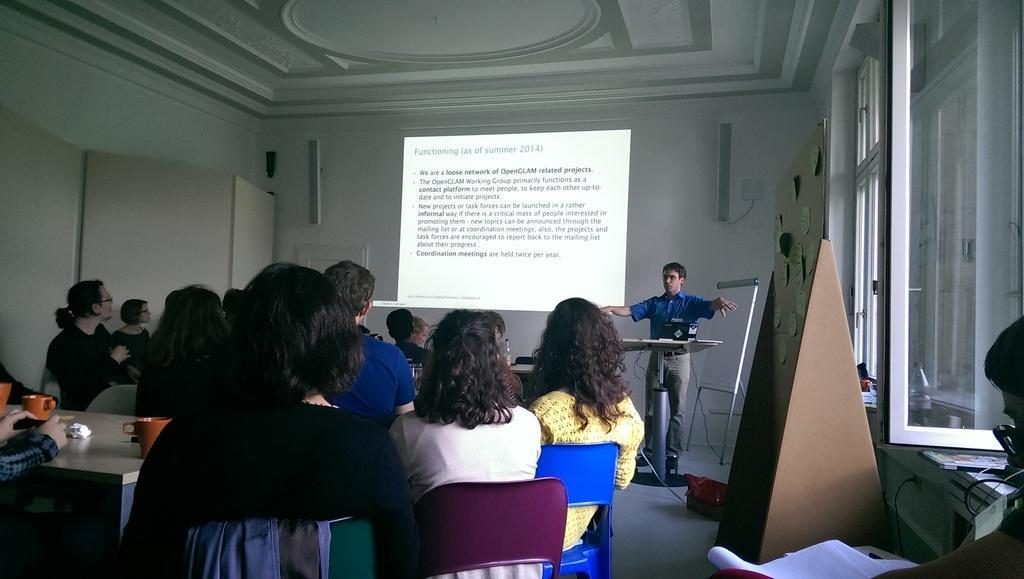How would you summarize this image in a sentence or two? In this image we can see people are sitting on chairs. Left bottom of the image table is there. On tables cups and tissue paper are there. Background of the image one person is standing. He is wearing blue color shirt and pant. In front of him podium is there. Behind him screen is present. Right bottom of the image one person is sitting and we can see white color papers. Right side of the image windows and brown color stand is there. The roof and walls are in white color. 